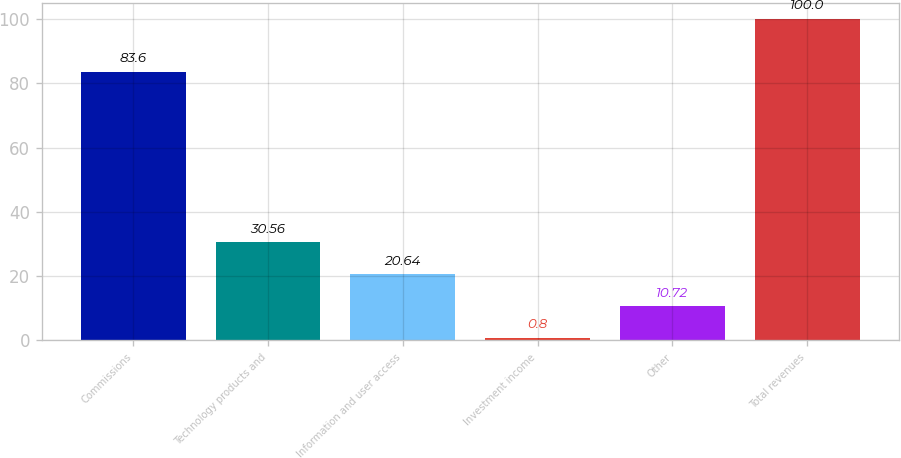Convert chart. <chart><loc_0><loc_0><loc_500><loc_500><bar_chart><fcel>Commissions<fcel>Technology products and<fcel>Information and user access<fcel>Investment income<fcel>Other<fcel>Total revenues<nl><fcel>83.6<fcel>30.56<fcel>20.64<fcel>0.8<fcel>10.72<fcel>100<nl></chart> 